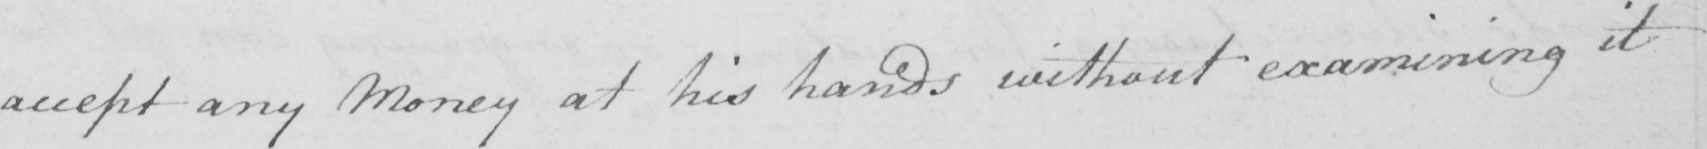What text is written in this handwritten line? accept any Money at his hands without examining it 